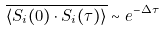Convert formula to latex. <formula><loc_0><loc_0><loc_500><loc_500>\overline { \langle S _ { i } ( 0 ) \cdot S _ { i } ( \tau ) \rangle } \sim e ^ { - \Delta \tau }</formula> 